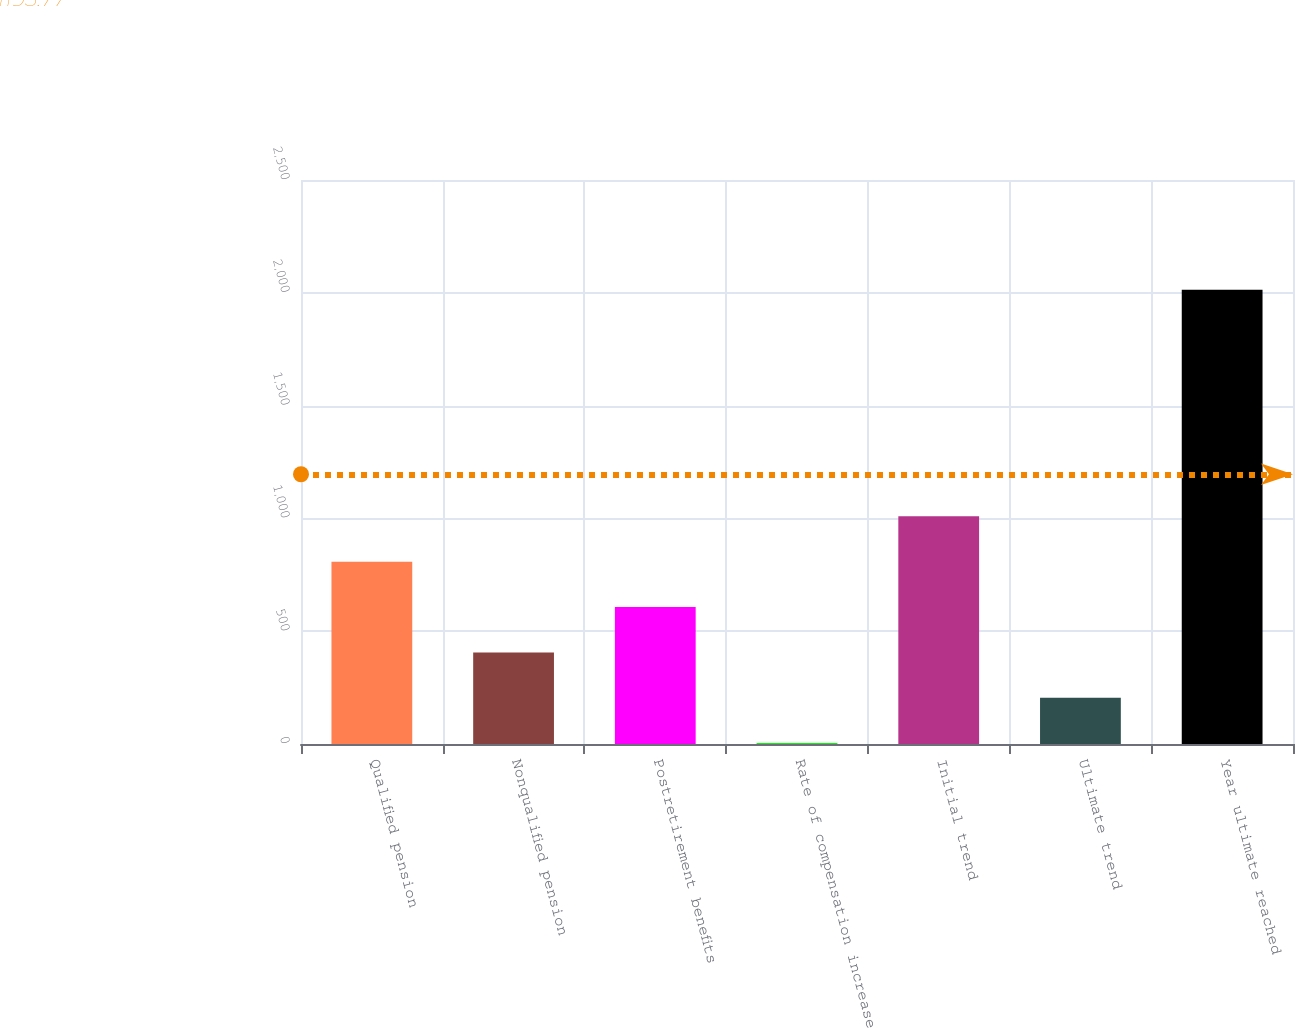Convert chart. <chart><loc_0><loc_0><loc_500><loc_500><bar_chart><fcel>Qualified pension<fcel>Nonqualified pension<fcel>Postretirement benefits<fcel>Rate of compensation increase<fcel>Initial trend<fcel>Ultimate trend<fcel>Year ultimate reached<nl><fcel>808<fcel>406<fcel>607<fcel>4<fcel>1009<fcel>205<fcel>2014<nl></chart> 